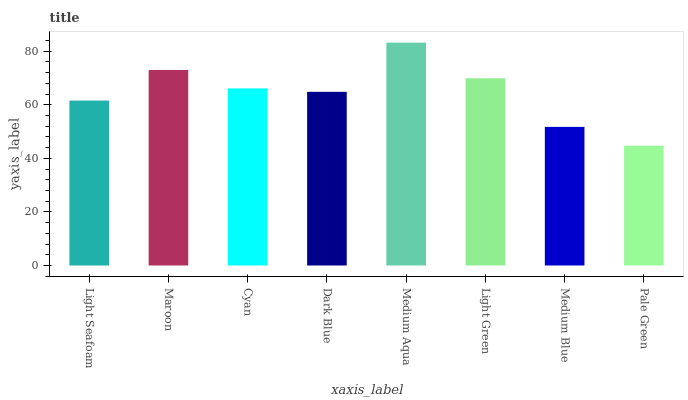Is Pale Green the minimum?
Answer yes or no. Yes. Is Medium Aqua the maximum?
Answer yes or no. Yes. Is Maroon the minimum?
Answer yes or no. No. Is Maroon the maximum?
Answer yes or no. No. Is Maroon greater than Light Seafoam?
Answer yes or no. Yes. Is Light Seafoam less than Maroon?
Answer yes or no. Yes. Is Light Seafoam greater than Maroon?
Answer yes or no. No. Is Maroon less than Light Seafoam?
Answer yes or no. No. Is Cyan the high median?
Answer yes or no. Yes. Is Dark Blue the low median?
Answer yes or no. Yes. Is Light Green the high median?
Answer yes or no. No. Is Medium Blue the low median?
Answer yes or no. No. 